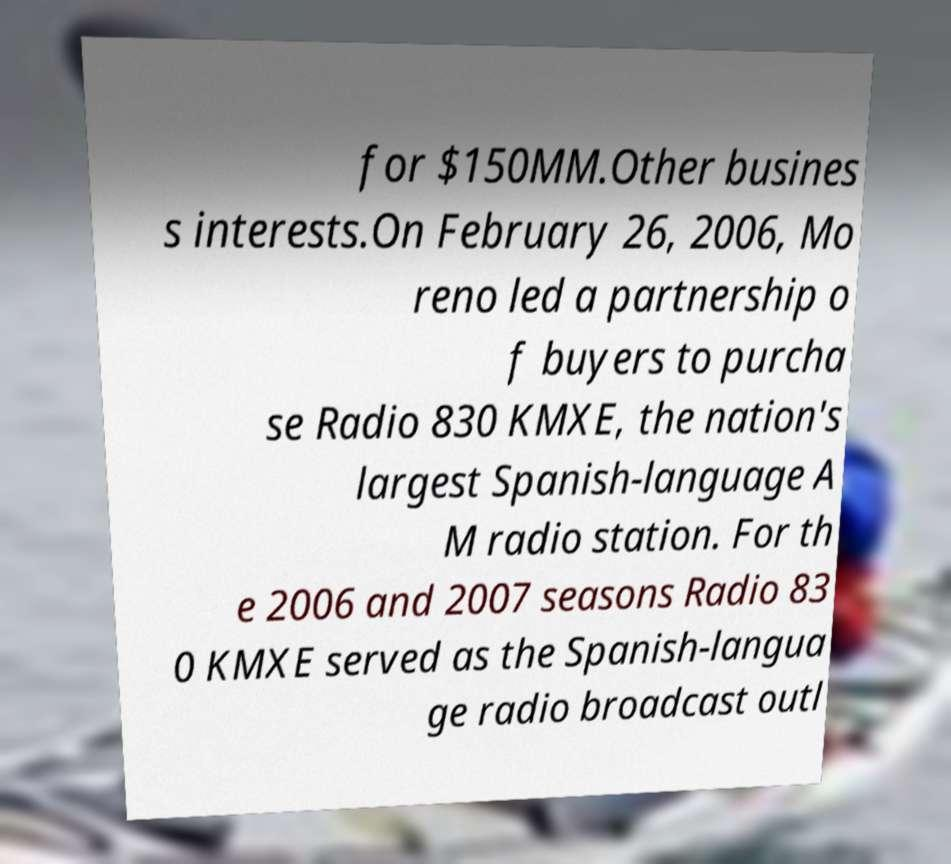Please read and relay the text visible in this image. What does it say? for $150MM.Other busines s interests.On February 26, 2006, Mo reno led a partnership o f buyers to purcha se Radio 830 KMXE, the nation's largest Spanish-language A M radio station. For th e 2006 and 2007 seasons Radio 83 0 KMXE served as the Spanish-langua ge radio broadcast outl 